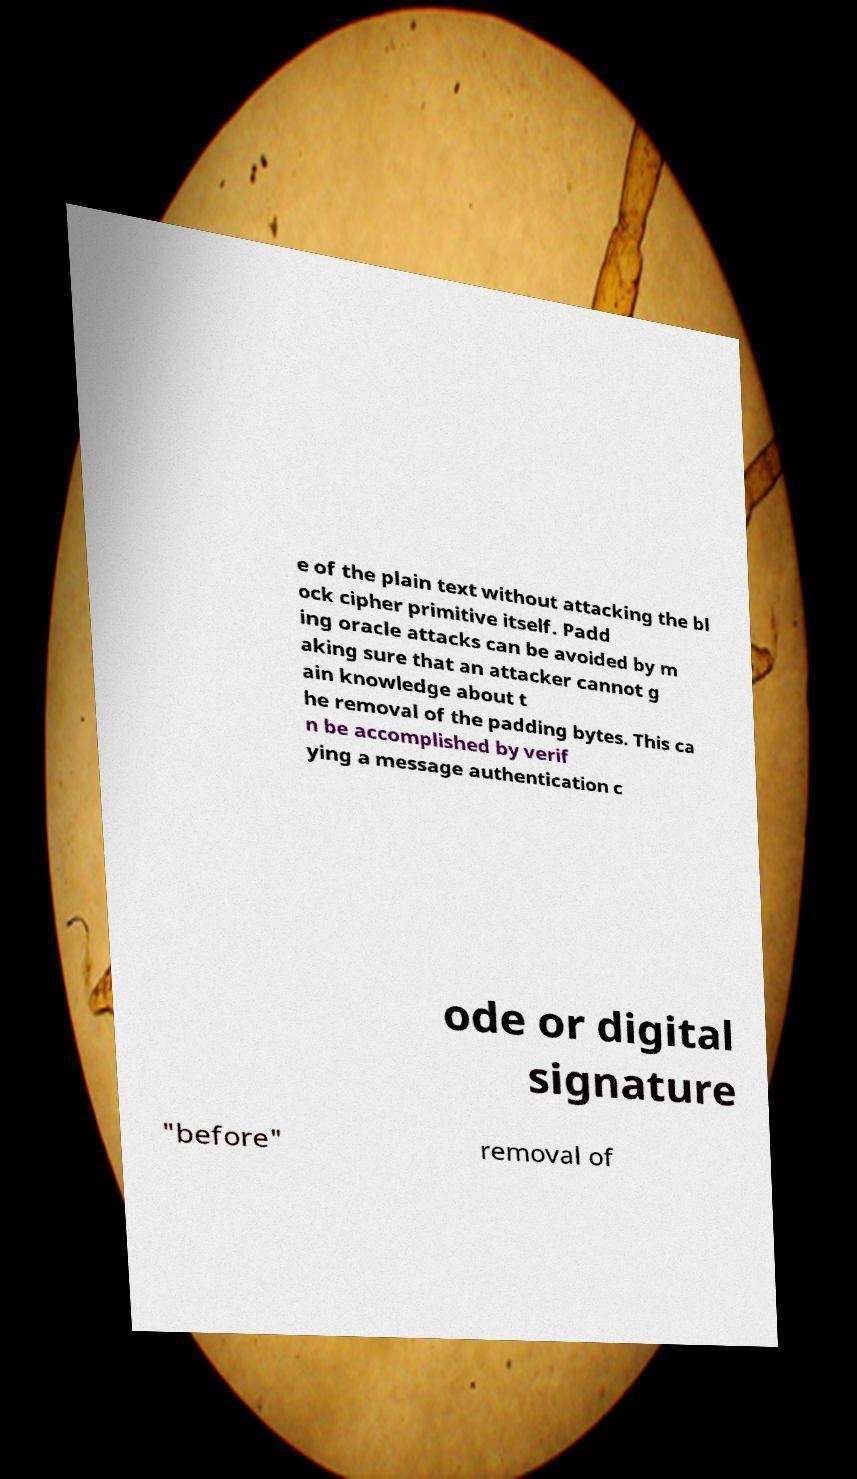Can you read and provide the text displayed in the image?This photo seems to have some interesting text. Can you extract and type it out for me? e of the plain text without attacking the bl ock cipher primitive itself. Padd ing oracle attacks can be avoided by m aking sure that an attacker cannot g ain knowledge about t he removal of the padding bytes. This ca n be accomplished by verif ying a message authentication c ode or digital signature "before" removal of 